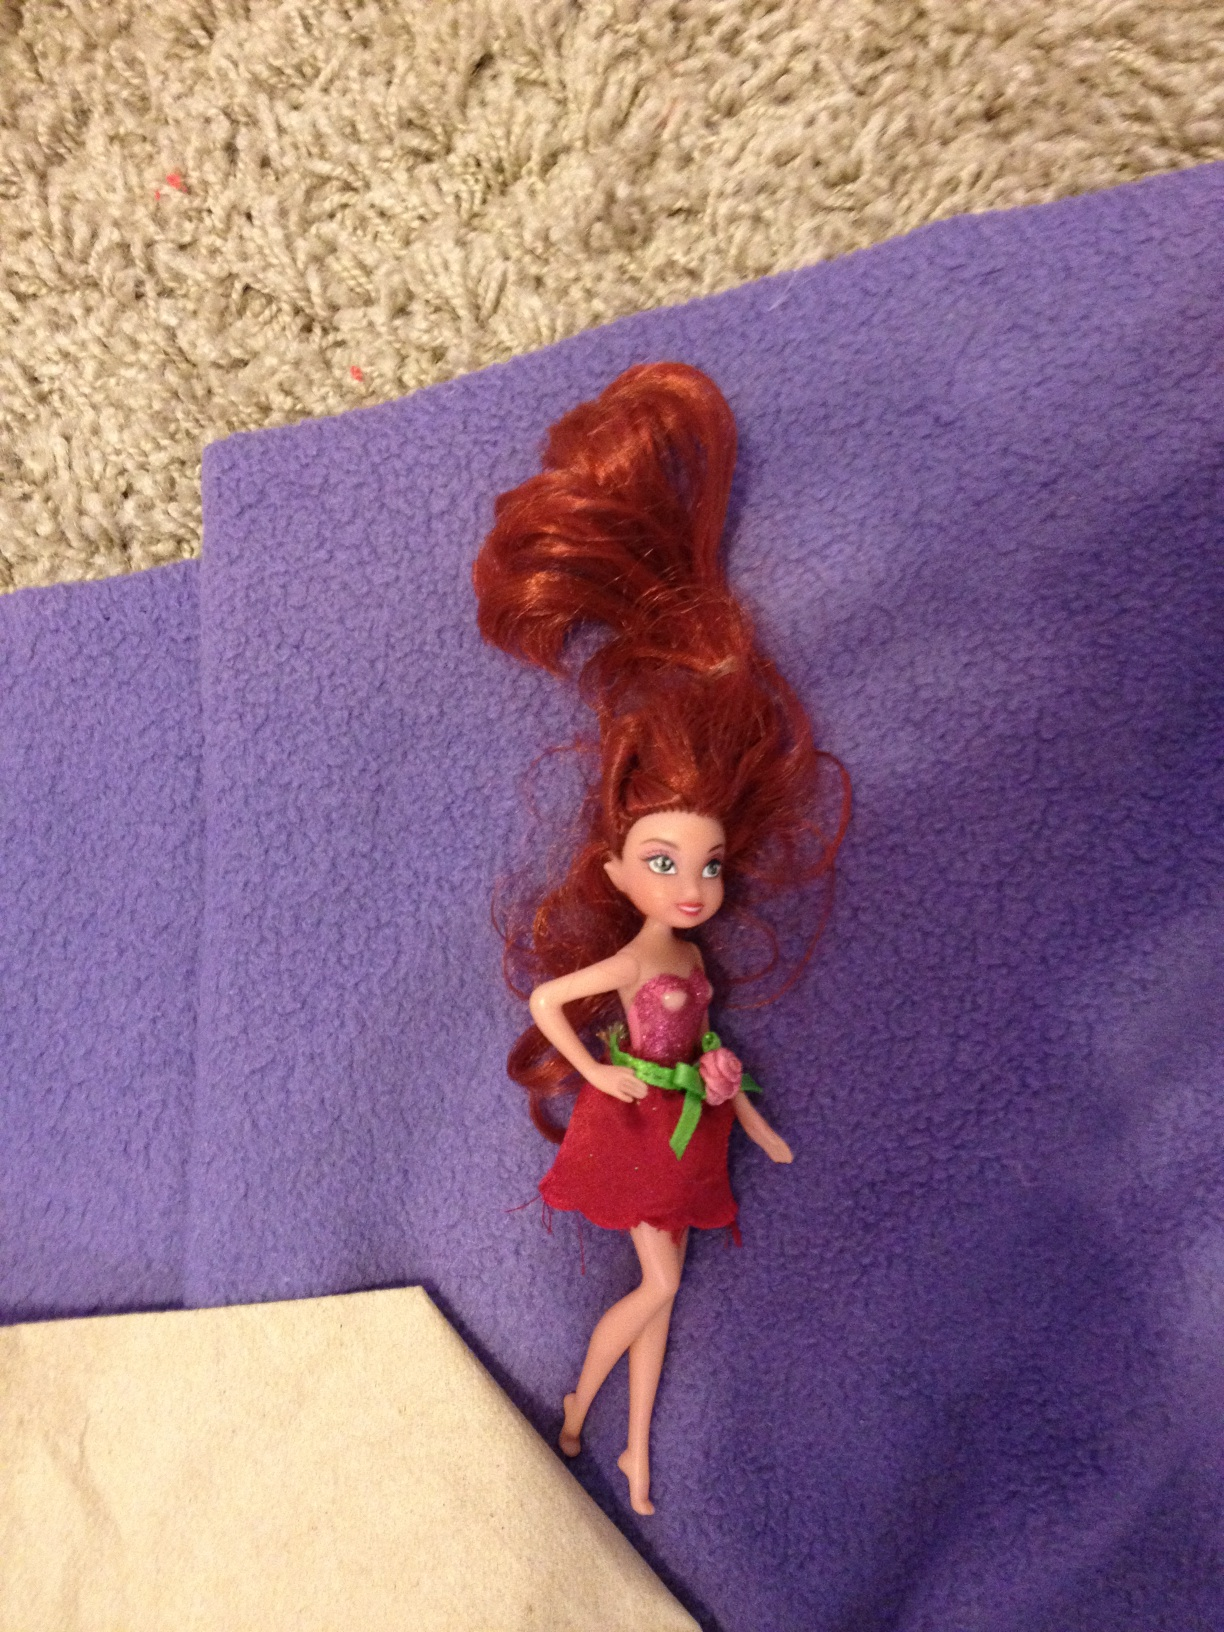Can you describe the object in the image? Certainly! The image shows a doll with reddish hair styled upright. It is wearing a red dress with a green ribbon and pink details. The doll is lying on a purple surface with an off-white edge. What can you tell me about the condition of the doll? The doll's hair appears to be somewhat disheveled, and it looks like it is not in a standing position, perhaps indicating that it is in a state of disarray or has been played with recently. 